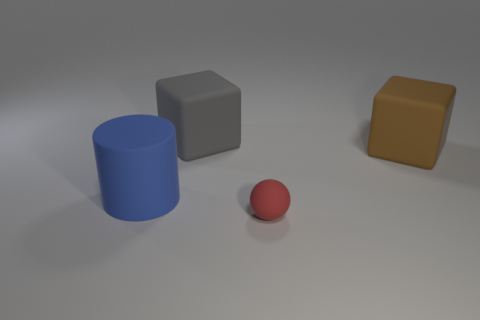What is the lighting source in this image? The image appears to have a singular overhead lighting source, as indicated by the shadows cast by the objects. The direction and softness of the shadows suggest that the light source is possibly out of the frame, above and slightly to the right of the objects from the viewer's perspective. Is there anything notable about the surface the objects are on? The surface appears smooth and exhibits a matte finish, creating a neutral background that emphasizes the objects. Its diffuse reflectivity suggests it could be a representation of a tabletop or a platform used for displaying or examining the objects. 